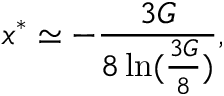Convert formula to latex. <formula><loc_0><loc_0><loc_500><loc_500>x ^ { * } \simeq - { \frac { 3 G } { 8 \ln ( { \frac { 3 G } { 8 } } ) } } ,</formula> 